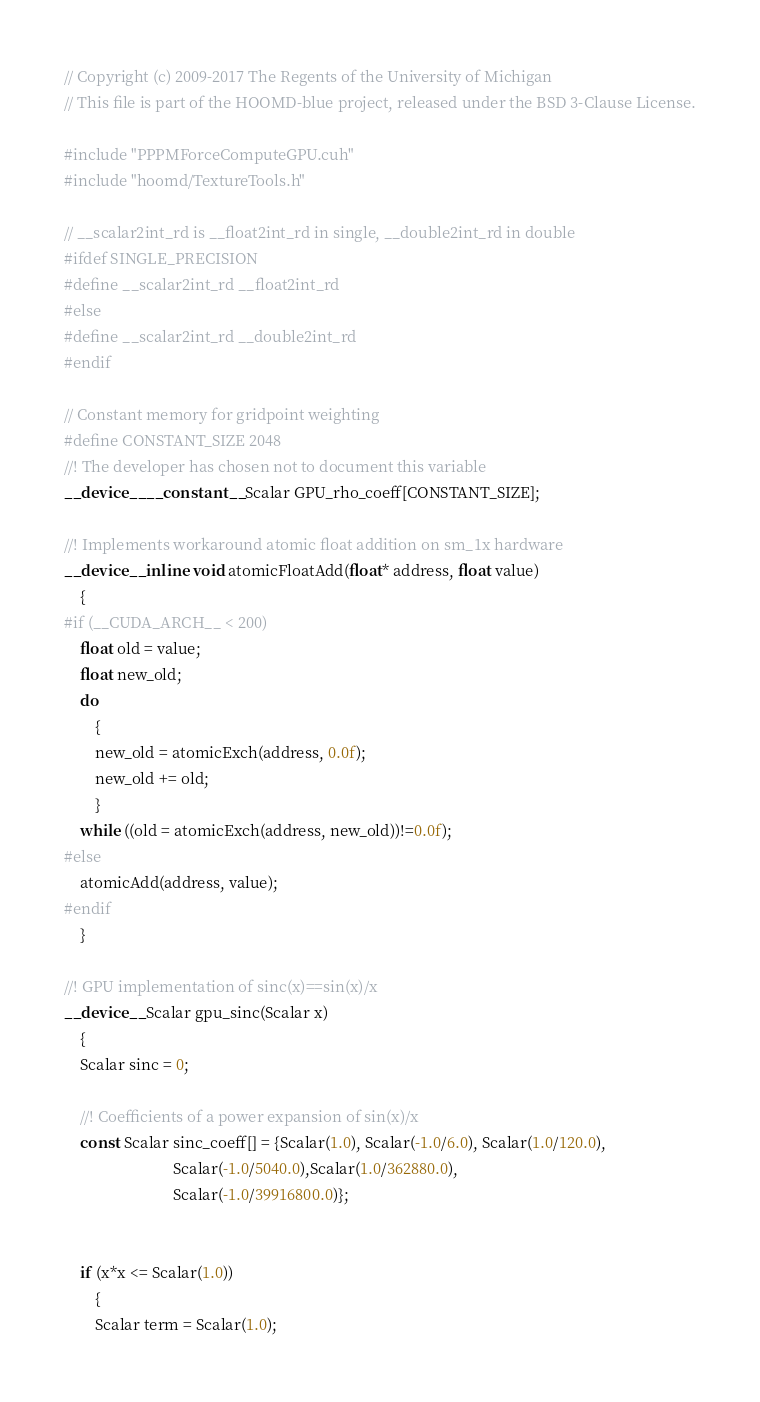Convert code to text. <code><loc_0><loc_0><loc_500><loc_500><_Cuda_>// Copyright (c) 2009-2017 The Regents of the University of Michigan
// This file is part of the HOOMD-blue project, released under the BSD 3-Clause License.

#include "PPPMForceComputeGPU.cuh"
#include "hoomd/TextureTools.h"

// __scalar2int_rd is __float2int_rd in single, __double2int_rd in double
#ifdef SINGLE_PRECISION
#define __scalar2int_rd __float2int_rd
#else
#define __scalar2int_rd __double2int_rd
#endif

// Constant memory for gridpoint weighting
#define CONSTANT_SIZE 2048
//! The developer has chosen not to document this variable
__device__ __constant__ Scalar GPU_rho_coeff[CONSTANT_SIZE];

//! Implements workaround atomic float addition on sm_1x hardware
__device__ inline void atomicFloatAdd(float* address, float value)
    {
#if (__CUDA_ARCH__ < 200)
    float old = value;
    float new_old;
    do
        {
        new_old = atomicExch(address, 0.0f);
        new_old += old;
        }
    while ((old = atomicExch(address, new_old))!=0.0f);
#else
    atomicAdd(address, value);
#endif
    }

//! GPU implementation of sinc(x)==sin(x)/x
__device__ Scalar gpu_sinc(Scalar x)
    {
    Scalar sinc = 0;

    //! Coefficients of a power expansion of sin(x)/x
    const Scalar sinc_coeff[] = {Scalar(1.0), Scalar(-1.0/6.0), Scalar(1.0/120.0),
                            Scalar(-1.0/5040.0),Scalar(1.0/362880.0),
                            Scalar(-1.0/39916800.0)};


    if (x*x <= Scalar(1.0))
        {
        Scalar term = Scalar(1.0);</code> 